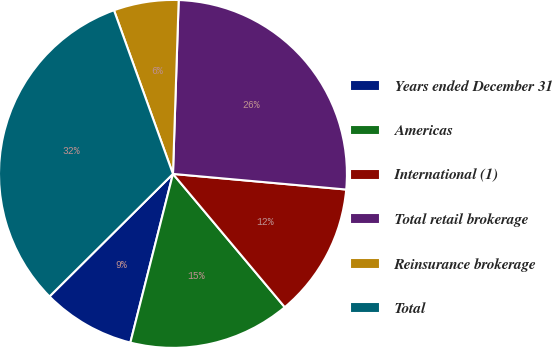Convert chart. <chart><loc_0><loc_0><loc_500><loc_500><pie_chart><fcel>Years ended December 31<fcel>Americas<fcel>International (1)<fcel>Total retail brokerage<fcel>Reinsurance brokerage<fcel>Total<nl><fcel>8.62%<fcel>15.05%<fcel>12.46%<fcel>25.91%<fcel>6.03%<fcel>31.94%<nl></chart> 